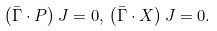Convert formula to latex. <formula><loc_0><loc_0><loc_500><loc_500>\left ( \bar { \Gamma } \cdot P \right ) J = 0 , \, \left ( \bar { \Gamma } \cdot X \right ) J = 0 .</formula> 